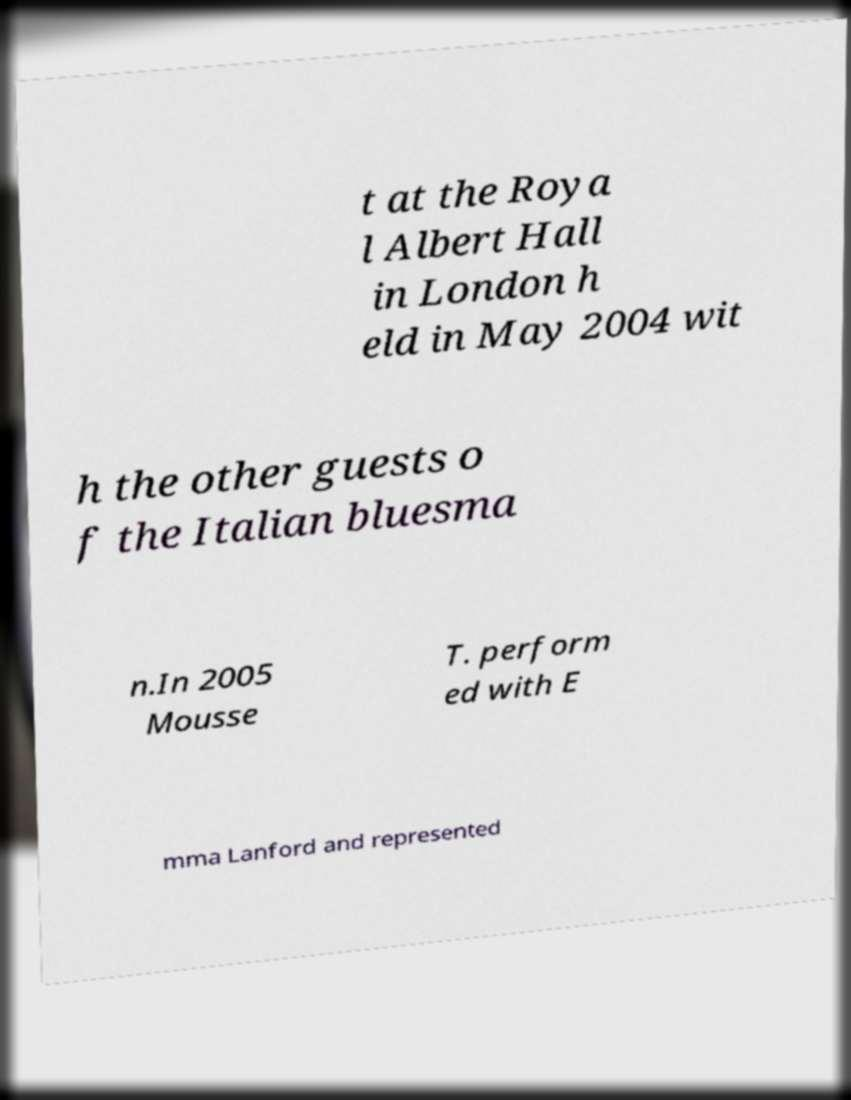Please read and relay the text visible in this image. What does it say? t at the Roya l Albert Hall in London h eld in May 2004 wit h the other guests o f the Italian bluesma n.In 2005 Mousse T. perform ed with E mma Lanford and represented 